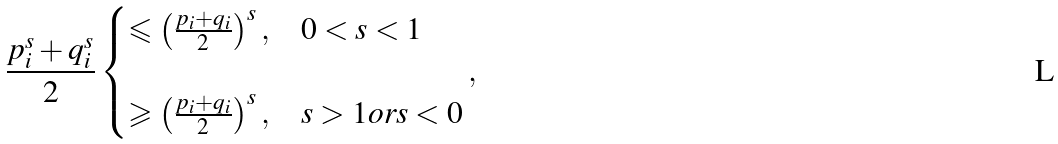Convert formula to latex. <formula><loc_0><loc_0><loc_500><loc_500>\frac { p _ { i } ^ { s } + q _ { i } ^ { s } } { 2 } \begin{cases} { \leqslant \left ( { \frac { p _ { i } + q _ { i } } { 2 } } \right ) ^ { s } , } & { 0 < s < 1 } \\ \\ { \geqslant \left ( { \frac { p _ { i } + q _ { i } } { 2 } } \right ) ^ { s } , } & { s > 1 o r s < 0 } \\ \end{cases} ,</formula> 